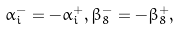Convert formula to latex. <formula><loc_0><loc_0><loc_500><loc_500>\alpha _ { i } ^ { - } = - \alpha _ { i } ^ { + } , \beta _ { 8 } ^ { - } = - \beta _ { 8 } ^ { + } ,</formula> 